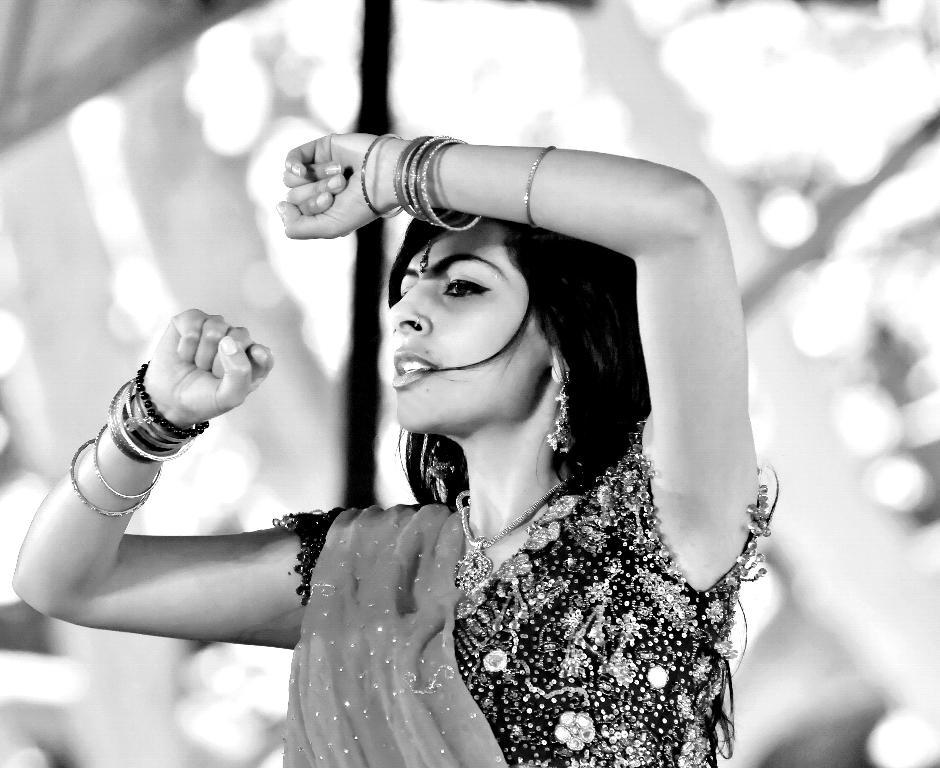What is the color scheme of the image? The image is black and white. What is the main subject of the image? There is a picture of a woman in the image. What is the woman wearing in the image? The woman is wearing a dress in the image. What type of apparatus is the woman using to generate new ideas in the image? There is no apparatus present in the image, and the woman is not generating new ideas. 